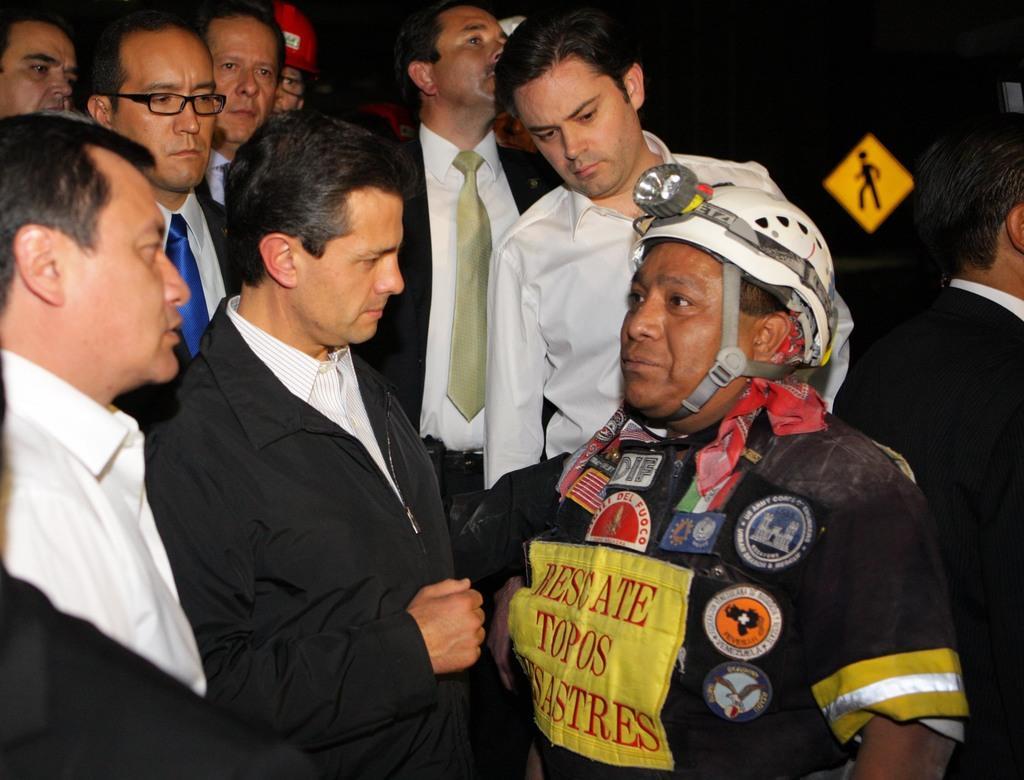In one or two sentences, can you explain what this image depicts? In this picture we can see a group of people, signboard, stickers and some of them wore blazers, ties, helmets and in the background it is dark. 